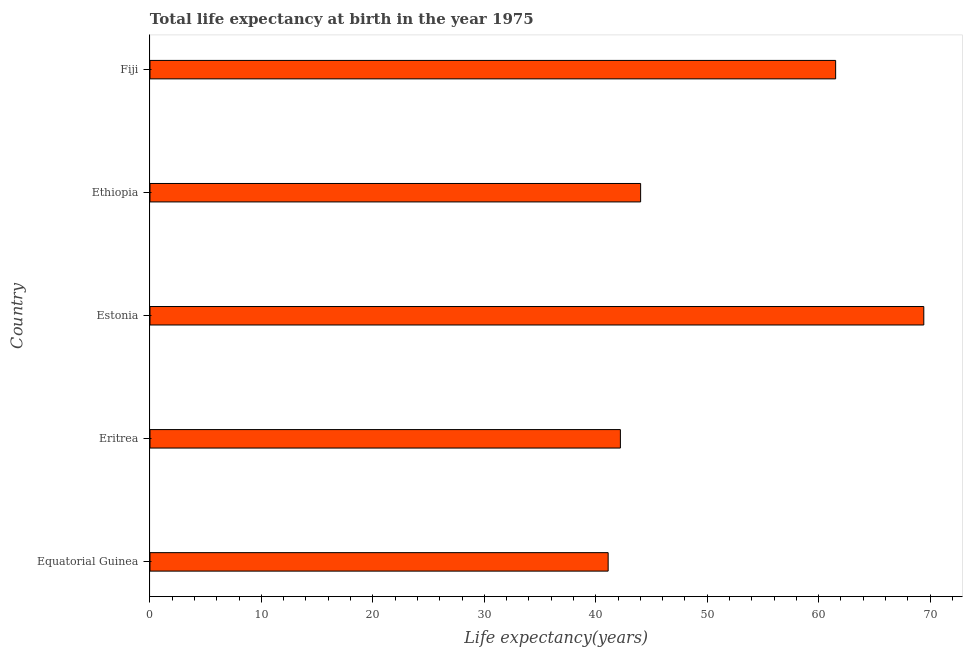Does the graph contain grids?
Give a very brief answer. No. What is the title of the graph?
Offer a very short reply. Total life expectancy at birth in the year 1975. What is the label or title of the X-axis?
Keep it short and to the point. Life expectancy(years). What is the label or title of the Y-axis?
Your response must be concise. Country. What is the life expectancy at birth in Equatorial Guinea?
Give a very brief answer. 41.12. Across all countries, what is the maximum life expectancy at birth?
Ensure brevity in your answer.  69.44. Across all countries, what is the minimum life expectancy at birth?
Your answer should be very brief. 41.12. In which country was the life expectancy at birth maximum?
Provide a short and direct response. Estonia. In which country was the life expectancy at birth minimum?
Provide a succinct answer. Equatorial Guinea. What is the sum of the life expectancy at birth?
Your answer should be compact. 258.34. What is the difference between the life expectancy at birth in Estonia and Fiji?
Give a very brief answer. 7.91. What is the average life expectancy at birth per country?
Ensure brevity in your answer.  51.67. What is the median life expectancy at birth?
Offer a terse response. 44.03. In how many countries, is the life expectancy at birth greater than 22 years?
Offer a very short reply. 5. Is the life expectancy at birth in Eritrea less than that in Fiji?
Your answer should be very brief. Yes. What is the difference between the highest and the second highest life expectancy at birth?
Your response must be concise. 7.91. What is the difference between the highest and the lowest life expectancy at birth?
Keep it short and to the point. 28.33. How many bars are there?
Keep it short and to the point. 5. What is the difference between two consecutive major ticks on the X-axis?
Give a very brief answer. 10. Are the values on the major ticks of X-axis written in scientific E-notation?
Keep it short and to the point. No. What is the Life expectancy(years) in Equatorial Guinea?
Offer a very short reply. 41.12. What is the Life expectancy(years) of Eritrea?
Offer a very short reply. 42.21. What is the Life expectancy(years) of Estonia?
Your response must be concise. 69.44. What is the Life expectancy(years) of Ethiopia?
Your answer should be very brief. 44.03. What is the Life expectancy(years) of Fiji?
Your response must be concise. 61.53. What is the difference between the Life expectancy(years) in Equatorial Guinea and Eritrea?
Give a very brief answer. -1.1. What is the difference between the Life expectancy(years) in Equatorial Guinea and Estonia?
Provide a succinct answer. -28.33. What is the difference between the Life expectancy(years) in Equatorial Guinea and Ethiopia?
Your answer should be compact. -2.91. What is the difference between the Life expectancy(years) in Equatorial Guinea and Fiji?
Your answer should be compact. -20.42. What is the difference between the Life expectancy(years) in Eritrea and Estonia?
Give a very brief answer. -27.23. What is the difference between the Life expectancy(years) in Eritrea and Ethiopia?
Offer a terse response. -1.82. What is the difference between the Life expectancy(years) in Eritrea and Fiji?
Offer a very short reply. -19.32. What is the difference between the Life expectancy(years) in Estonia and Ethiopia?
Make the answer very short. 25.41. What is the difference between the Life expectancy(years) in Estonia and Fiji?
Provide a short and direct response. 7.91. What is the difference between the Life expectancy(years) in Ethiopia and Fiji?
Your answer should be compact. -17.5. What is the ratio of the Life expectancy(years) in Equatorial Guinea to that in Eritrea?
Give a very brief answer. 0.97. What is the ratio of the Life expectancy(years) in Equatorial Guinea to that in Estonia?
Make the answer very short. 0.59. What is the ratio of the Life expectancy(years) in Equatorial Guinea to that in Ethiopia?
Keep it short and to the point. 0.93. What is the ratio of the Life expectancy(years) in Equatorial Guinea to that in Fiji?
Provide a succinct answer. 0.67. What is the ratio of the Life expectancy(years) in Eritrea to that in Estonia?
Ensure brevity in your answer.  0.61. What is the ratio of the Life expectancy(years) in Eritrea to that in Ethiopia?
Offer a terse response. 0.96. What is the ratio of the Life expectancy(years) in Eritrea to that in Fiji?
Ensure brevity in your answer.  0.69. What is the ratio of the Life expectancy(years) in Estonia to that in Ethiopia?
Provide a succinct answer. 1.58. What is the ratio of the Life expectancy(years) in Estonia to that in Fiji?
Ensure brevity in your answer.  1.13. What is the ratio of the Life expectancy(years) in Ethiopia to that in Fiji?
Ensure brevity in your answer.  0.72. 